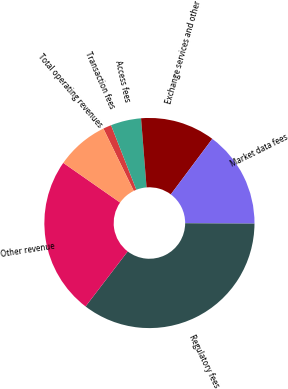<chart> <loc_0><loc_0><loc_500><loc_500><pie_chart><fcel>Transaction fees<fcel>Access fees<fcel>Exchange services and other<fcel>Market data fees<fcel>Regulatory fees<fcel>Other revenue<fcel>Total operating revenues<nl><fcel>1.27%<fcel>4.68%<fcel>11.48%<fcel>14.88%<fcel>35.3%<fcel>24.3%<fcel>8.08%<nl></chart> 